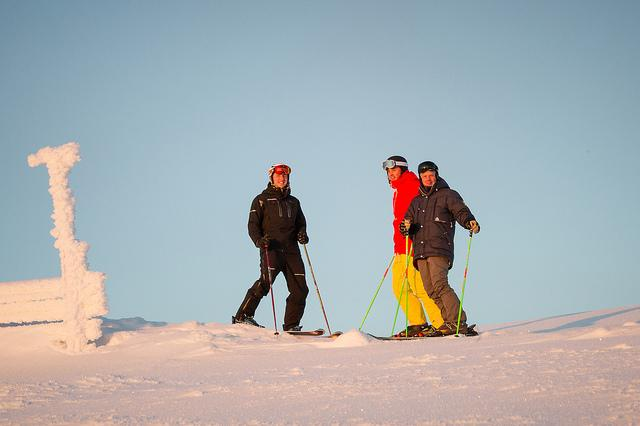Where will these men go next?

Choices:
A) up hill
B) nowhere
C) leftward
D) down hill down hill 